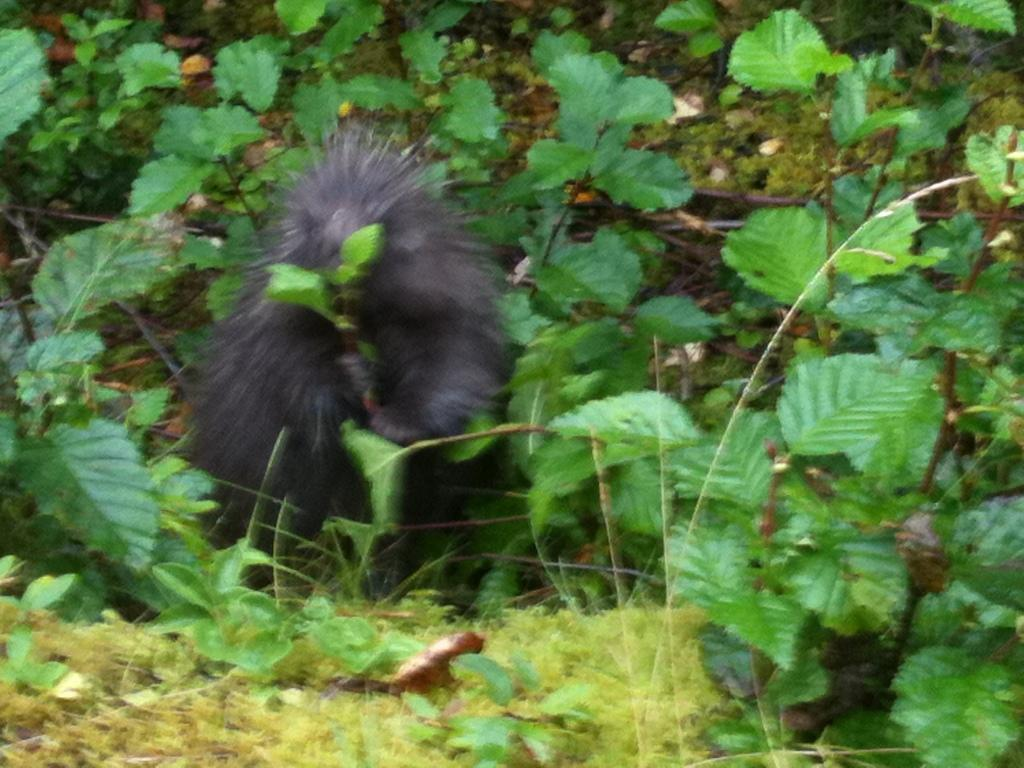What is the main subject in the center of the image? There is an animal present in the center of the image. What type of vegetation can be seen in the image? There are leaves and grass in the image. What type of quilt is being used to cover the animal in the image? There is no quilt present in the image; it only features an animal, leaves, and grass. 